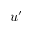<formula> <loc_0><loc_0><loc_500><loc_500>u ^ { \prime }</formula> 